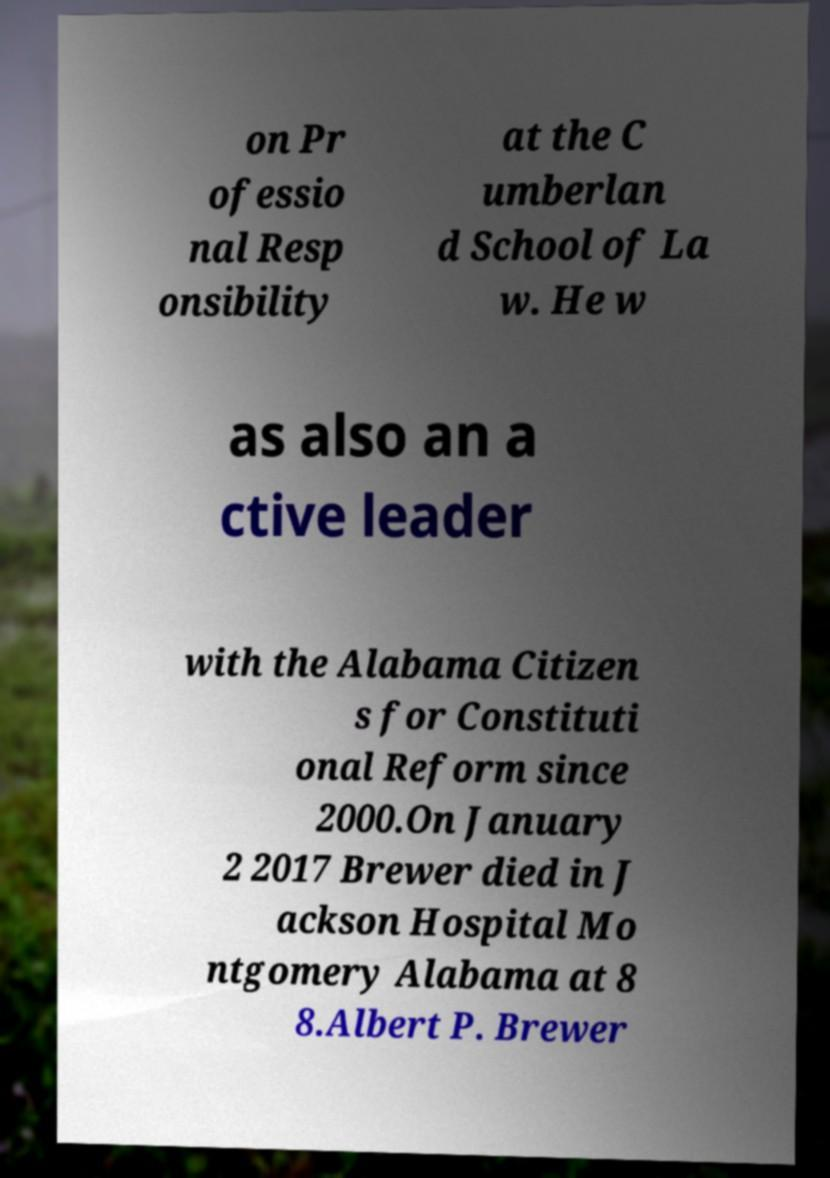Please read and relay the text visible in this image. What does it say? on Pr ofessio nal Resp onsibility at the C umberlan d School of La w. He w as also an a ctive leader with the Alabama Citizen s for Constituti onal Reform since 2000.On January 2 2017 Brewer died in J ackson Hospital Mo ntgomery Alabama at 8 8.Albert P. Brewer 